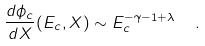Convert formula to latex. <formula><loc_0><loc_0><loc_500><loc_500>\frac { d \phi _ { c } } { d X } ( E _ { c } , X ) \sim E _ { c } ^ { - \gamma - 1 + \lambda } \ \ .</formula> 